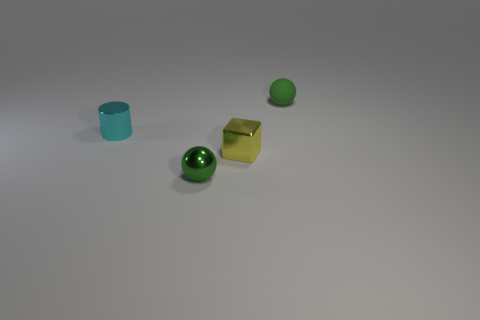Add 1 small cubes. How many objects exist? 5 Subtract all cubes. How many objects are left? 3 Add 2 small cyan cylinders. How many small cyan cylinders are left? 3 Add 1 big yellow shiny objects. How many big yellow shiny objects exist? 1 Subtract 0 red spheres. How many objects are left? 4 Subtract all large purple matte objects. Subtract all green rubber things. How many objects are left? 3 